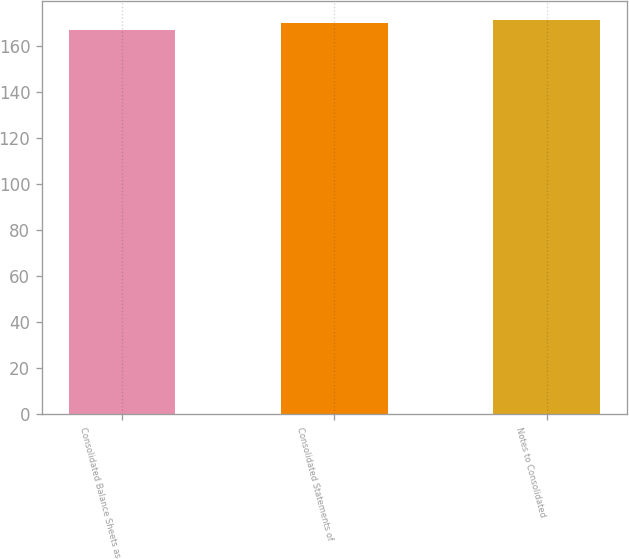Convert chart to OTSL. <chart><loc_0><loc_0><loc_500><loc_500><bar_chart><fcel>Consolidated Balance Sheets as<fcel>Consolidated Statements of<fcel>Notes to Consolidated<nl><fcel>167<fcel>170<fcel>171<nl></chart> 